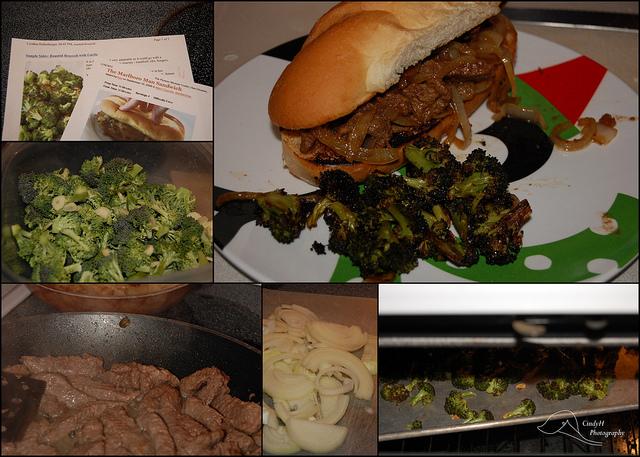What color is the plate?
Quick response, please. White. Are those leaflets at the edge of the foot?
Quick response, please. Yes. How many different ingredients do you see?
Quick response, please. 3. 